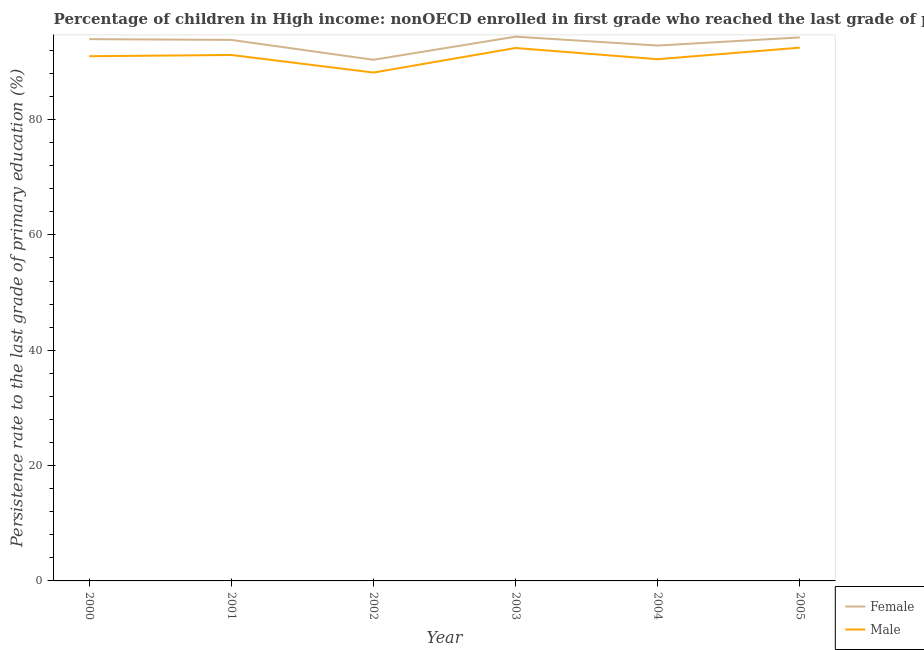Is the number of lines equal to the number of legend labels?
Ensure brevity in your answer.  Yes. What is the persistence rate of female students in 2004?
Provide a succinct answer. 92.84. Across all years, what is the maximum persistence rate of male students?
Give a very brief answer. 92.48. Across all years, what is the minimum persistence rate of male students?
Offer a very short reply. 88.16. In which year was the persistence rate of female students maximum?
Make the answer very short. 2003. What is the total persistence rate of male students in the graph?
Keep it short and to the point. 545.72. What is the difference between the persistence rate of female students in 2000 and that in 2004?
Keep it short and to the point. 1.11. What is the difference between the persistence rate of male students in 2005 and the persistence rate of female students in 2002?
Give a very brief answer. 2.1. What is the average persistence rate of male students per year?
Provide a short and direct response. 90.95. In the year 2001, what is the difference between the persistence rate of female students and persistence rate of male students?
Your answer should be very brief. 2.62. What is the ratio of the persistence rate of female students in 2004 to that in 2005?
Give a very brief answer. 0.99. What is the difference between the highest and the second highest persistence rate of female students?
Provide a succinct answer. 0.13. What is the difference between the highest and the lowest persistence rate of female students?
Your answer should be very brief. 4.01. Is the sum of the persistence rate of female students in 2001 and 2002 greater than the maximum persistence rate of male students across all years?
Make the answer very short. Yes. How many lines are there?
Offer a terse response. 2. How many years are there in the graph?
Keep it short and to the point. 6. What is the difference between two consecutive major ticks on the Y-axis?
Ensure brevity in your answer.  20. Are the values on the major ticks of Y-axis written in scientific E-notation?
Give a very brief answer. No. Does the graph contain any zero values?
Your answer should be compact. No. Where does the legend appear in the graph?
Provide a succinct answer. Bottom right. How many legend labels are there?
Your response must be concise. 2. How are the legend labels stacked?
Give a very brief answer. Vertical. What is the title of the graph?
Your answer should be compact. Percentage of children in High income: nonOECD enrolled in first grade who reached the last grade of primary education. What is the label or title of the X-axis?
Your answer should be compact. Year. What is the label or title of the Y-axis?
Provide a short and direct response. Persistence rate to the last grade of primary education (%). What is the Persistence rate to the last grade of primary education (%) in Female in 2000?
Your answer should be very brief. 93.95. What is the Persistence rate to the last grade of primary education (%) in Male in 2000?
Keep it short and to the point. 90.99. What is the Persistence rate to the last grade of primary education (%) of Female in 2001?
Your answer should be very brief. 93.82. What is the Persistence rate to the last grade of primary education (%) of Male in 2001?
Give a very brief answer. 91.21. What is the Persistence rate to the last grade of primary education (%) in Female in 2002?
Ensure brevity in your answer.  90.37. What is the Persistence rate to the last grade of primary education (%) of Male in 2002?
Your answer should be compact. 88.16. What is the Persistence rate to the last grade of primary education (%) in Female in 2003?
Your answer should be compact. 94.38. What is the Persistence rate to the last grade of primary education (%) of Male in 2003?
Offer a very short reply. 92.42. What is the Persistence rate to the last grade of primary education (%) in Female in 2004?
Your response must be concise. 92.84. What is the Persistence rate to the last grade of primary education (%) in Male in 2004?
Your answer should be compact. 90.47. What is the Persistence rate to the last grade of primary education (%) of Female in 2005?
Provide a short and direct response. 94.25. What is the Persistence rate to the last grade of primary education (%) in Male in 2005?
Provide a succinct answer. 92.48. Across all years, what is the maximum Persistence rate to the last grade of primary education (%) in Female?
Ensure brevity in your answer.  94.38. Across all years, what is the maximum Persistence rate to the last grade of primary education (%) of Male?
Your answer should be very brief. 92.48. Across all years, what is the minimum Persistence rate to the last grade of primary education (%) of Female?
Provide a short and direct response. 90.37. Across all years, what is the minimum Persistence rate to the last grade of primary education (%) of Male?
Your response must be concise. 88.16. What is the total Persistence rate to the last grade of primary education (%) of Female in the graph?
Your response must be concise. 559.62. What is the total Persistence rate to the last grade of primary education (%) in Male in the graph?
Provide a short and direct response. 545.72. What is the difference between the Persistence rate to the last grade of primary education (%) of Female in 2000 and that in 2001?
Your answer should be very brief. 0.13. What is the difference between the Persistence rate to the last grade of primary education (%) of Male in 2000 and that in 2001?
Provide a succinct answer. -0.21. What is the difference between the Persistence rate to the last grade of primary education (%) of Female in 2000 and that in 2002?
Ensure brevity in your answer.  3.58. What is the difference between the Persistence rate to the last grade of primary education (%) of Male in 2000 and that in 2002?
Offer a terse response. 2.83. What is the difference between the Persistence rate to the last grade of primary education (%) of Female in 2000 and that in 2003?
Provide a succinct answer. -0.43. What is the difference between the Persistence rate to the last grade of primary education (%) in Male in 2000 and that in 2003?
Provide a succinct answer. -1.43. What is the difference between the Persistence rate to the last grade of primary education (%) of Female in 2000 and that in 2004?
Your answer should be very brief. 1.11. What is the difference between the Persistence rate to the last grade of primary education (%) in Male in 2000 and that in 2004?
Offer a very short reply. 0.52. What is the difference between the Persistence rate to the last grade of primary education (%) in Female in 2000 and that in 2005?
Provide a short and direct response. -0.3. What is the difference between the Persistence rate to the last grade of primary education (%) in Male in 2000 and that in 2005?
Your response must be concise. -1.48. What is the difference between the Persistence rate to the last grade of primary education (%) of Female in 2001 and that in 2002?
Give a very brief answer. 3.45. What is the difference between the Persistence rate to the last grade of primary education (%) of Male in 2001 and that in 2002?
Offer a terse response. 3.05. What is the difference between the Persistence rate to the last grade of primary education (%) in Female in 2001 and that in 2003?
Provide a succinct answer. -0.56. What is the difference between the Persistence rate to the last grade of primary education (%) of Male in 2001 and that in 2003?
Provide a short and direct response. -1.21. What is the difference between the Persistence rate to the last grade of primary education (%) in Female in 2001 and that in 2004?
Your response must be concise. 0.98. What is the difference between the Persistence rate to the last grade of primary education (%) in Male in 2001 and that in 2004?
Make the answer very short. 0.73. What is the difference between the Persistence rate to the last grade of primary education (%) in Female in 2001 and that in 2005?
Keep it short and to the point. -0.43. What is the difference between the Persistence rate to the last grade of primary education (%) of Male in 2001 and that in 2005?
Your answer should be very brief. -1.27. What is the difference between the Persistence rate to the last grade of primary education (%) of Female in 2002 and that in 2003?
Your response must be concise. -4.01. What is the difference between the Persistence rate to the last grade of primary education (%) in Male in 2002 and that in 2003?
Your response must be concise. -4.26. What is the difference between the Persistence rate to the last grade of primary education (%) of Female in 2002 and that in 2004?
Keep it short and to the point. -2.47. What is the difference between the Persistence rate to the last grade of primary education (%) of Male in 2002 and that in 2004?
Ensure brevity in your answer.  -2.32. What is the difference between the Persistence rate to the last grade of primary education (%) of Female in 2002 and that in 2005?
Your answer should be compact. -3.88. What is the difference between the Persistence rate to the last grade of primary education (%) of Male in 2002 and that in 2005?
Give a very brief answer. -4.32. What is the difference between the Persistence rate to the last grade of primary education (%) in Female in 2003 and that in 2004?
Provide a succinct answer. 1.54. What is the difference between the Persistence rate to the last grade of primary education (%) in Male in 2003 and that in 2004?
Provide a short and direct response. 1.94. What is the difference between the Persistence rate to the last grade of primary education (%) in Female in 2003 and that in 2005?
Your answer should be very brief. 0.13. What is the difference between the Persistence rate to the last grade of primary education (%) in Male in 2003 and that in 2005?
Your answer should be very brief. -0.06. What is the difference between the Persistence rate to the last grade of primary education (%) of Female in 2004 and that in 2005?
Give a very brief answer. -1.41. What is the difference between the Persistence rate to the last grade of primary education (%) in Male in 2004 and that in 2005?
Your answer should be compact. -2. What is the difference between the Persistence rate to the last grade of primary education (%) in Female in 2000 and the Persistence rate to the last grade of primary education (%) in Male in 2001?
Provide a succinct answer. 2.75. What is the difference between the Persistence rate to the last grade of primary education (%) in Female in 2000 and the Persistence rate to the last grade of primary education (%) in Male in 2002?
Provide a short and direct response. 5.79. What is the difference between the Persistence rate to the last grade of primary education (%) in Female in 2000 and the Persistence rate to the last grade of primary education (%) in Male in 2003?
Your answer should be compact. 1.54. What is the difference between the Persistence rate to the last grade of primary education (%) in Female in 2000 and the Persistence rate to the last grade of primary education (%) in Male in 2004?
Make the answer very short. 3.48. What is the difference between the Persistence rate to the last grade of primary education (%) in Female in 2000 and the Persistence rate to the last grade of primary education (%) in Male in 2005?
Give a very brief answer. 1.48. What is the difference between the Persistence rate to the last grade of primary education (%) of Female in 2001 and the Persistence rate to the last grade of primary education (%) of Male in 2002?
Your answer should be compact. 5.66. What is the difference between the Persistence rate to the last grade of primary education (%) in Female in 2001 and the Persistence rate to the last grade of primary education (%) in Male in 2003?
Your response must be concise. 1.4. What is the difference between the Persistence rate to the last grade of primary education (%) of Female in 2001 and the Persistence rate to the last grade of primary education (%) of Male in 2004?
Make the answer very short. 3.35. What is the difference between the Persistence rate to the last grade of primary education (%) in Female in 2001 and the Persistence rate to the last grade of primary education (%) in Male in 2005?
Offer a terse response. 1.34. What is the difference between the Persistence rate to the last grade of primary education (%) of Female in 2002 and the Persistence rate to the last grade of primary education (%) of Male in 2003?
Provide a succinct answer. -2.04. What is the difference between the Persistence rate to the last grade of primary education (%) in Female in 2002 and the Persistence rate to the last grade of primary education (%) in Male in 2004?
Your answer should be compact. -0.1. What is the difference between the Persistence rate to the last grade of primary education (%) of Female in 2002 and the Persistence rate to the last grade of primary education (%) of Male in 2005?
Ensure brevity in your answer.  -2.1. What is the difference between the Persistence rate to the last grade of primary education (%) in Female in 2003 and the Persistence rate to the last grade of primary education (%) in Male in 2004?
Ensure brevity in your answer.  3.91. What is the difference between the Persistence rate to the last grade of primary education (%) in Female in 2003 and the Persistence rate to the last grade of primary education (%) in Male in 2005?
Your response must be concise. 1.9. What is the difference between the Persistence rate to the last grade of primary education (%) in Female in 2004 and the Persistence rate to the last grade of primary education (%) in Male in 2005?
Your response must be concise. 0.37. What is the average Persistence rate to the last grade of primary education (%) in Female per year?
Ensure brevity in your answer.  93.27. What is the average Persistence rate to the last grade of primary education (%) in Male per year?
Provide a short and direct response. 90.95. In the year 2000, what is the difference between the Persistence rate to the last grade of primary education (%) of Female and Persistence rate to the last grade of primary education (%) of Male?
Keep it short and to the point. 2.96. In the year 2001, what is the difference between the Persistence rate to the last grade of primary education (%) of Female and Persistence rate to the last grade of primary education (%) of Male?
Your response must be concise. 2.62. In the year 2002, what is the difference between the Persistence rate to the last grade of primary education (%) in Female and Persistence rate to the last grade of primary education (%) in Male?
Your answer should be very brief. 2.22. In the year 2003, what is the difference between the Persistence rate to the last grade of primary education (%) of Female and Persistence rate to the last grade of primary education (%) of Male?
Ensure brevity in your answer.  1.96. In the year 2004, what is the difference between the Persistence rate to the last grade of primary education (%) in Female and Persistence rate to the last grade of primary education (%) in Male?
Your answer should be very brief. 2.37. In the year 2005, what is the difference between the Persistence rate to the last grade of primary education (%) in Female and Persistence rate to the last grade of primary education (%) in Male?
Keep it short and to the point. 1.77. What is the ratio of the Persistence rate to the last grade of primary education (%) in Female in 2000 to that in 2002?
Keep it short and to the point. 1.04. What is the ratio of the Persistence rate to the last grade of primary education (%) of Male in 2000 to that in 2002?
Provide a succinct answer. 1.03. What is the ratio of the Persistence rate to the last grade of primary education (%) of Female in 2000 to that in 2003?
Give a very brief answer. 1. What is the ratio of the Persistence rate to the last grade of primary education (%) of Male in 2000 to that in 2003?
Provide a short and direct response. 0.98. What is the ratio of the Persistence rate to the last grade of primary education (%) of Male in 2000 to that in 2004?
Your answer should be compact. 1.01. What is the ratio of the Persistence rate to the last grade of primary education (%) of Female in 2000 to that in 2005?
Keep it short and to the point. 1. What is the ratio of the Persistence rate to the last grade of primary education (%) of Male in 2000 to that in 2005?
Offer a very short reply. 0.98. What is the ratio of the Persistence rate to the last grade of primary education (%) in Female in 2001 to that in 2002?
Your answer should be very brief. 1.04. What is the ratio of the Persistence rate to the last grade of primary education (%) of Male in 2001 to that in 2002?
Your answer should be compact. 1.03. What is the ratio of the Persistence rate to the last grade of primary education (%) of Female in 2001 to that in 2003?
Ensure brevity in your answer.  0.99. What is the ratio of the Persistence rate to the last grade of primary education (%) of Male in 2001 to that in 2003?
Offer a terse response. 0.99. What is the ratio of the Persistence rate to the last grade of primary education (%) of Female in 2001 to that in 2004?
Give a very brief answer. 1.01. What is the ratio of the Persistence rate to the last grade of primary education (%) in Male in 2001 to that in 2004?
Provide a short and direct response. 1.01. What is the ratio of the Persistence rate to the last grade of primary education (%) of Female in 2001 to that in 2005?
Make the answer very short. 1. What is the ratio of the Persistence rate to the last grade of primary education (%) in Male in 2001 to that in 2005?
Your answer should be very brief. 0.99. What is the ratio of the Persistence rate to the last grade of primary education (%) of Female in 2002 to that in 2003?
Your response must be concise. 0.96. What is the ratio of the Persistence rate to the last grade of primary education (%) in Male in 2002 to that in 2003?
Keep it short and to the point. 0.95. What is the ratio of the Persistence rate to the last grade of primary education (%) in Female in 2002 to that in 2004?
Your response must be concise. 0.97. What is the ratio of the Persistence rate to the last grade of primary education (%) of Male in 2002 to that in 2004?
Keep it short and to the point. 0.97. What is the ratio of the Persistence rate to the last grade of primary education (%) in Female in 2002 to that in 2005?
Offer a very short reply. 0.96. What is the ratio of the Persistence rate to the last grade of primary education (%) in Male in 2002 to that in 2005?
Provide a short and direct response. 0.95. What is the ratio of the Persistence rate to the last grade of primary education (%) in Female in 2003 to that in 2004?
Keep it short and to the point. 1.02. What is the ratio of the Persistence rate to the last grade of primary education (%) of Male in 2003 to that in 2004?
Provide a short and direct response. 1.02. What is the ratio of the Persistence rate to the last grade of primary education (%) of Female in 2004 to that in 2005?
Your answer should be very brief. 0.99. What is the ratio of the Persistence rate to the last grade of primary education (%) in Male in 2004 to that in 2005?
Give a very brief answer. 0.98. What is the difference between the highest and the second highest Persistence rate to the last grade of primary education (%) in Female?
Ensure brevity in your answer.  0.13. What is the difference between the highest and the second highest Persistence rate to the last grade of primary education (%) in Male?
Your answer should be very brief. 0.06. What is the difference between the highest and the lowest Persistence rate to the last grade of primary education (%) of Female?
Make the answer very short. 4.01. What is the difference between the highest and the lowest Persistence rate to the last grade of primary education (%) of Male?
Offer a very short reply. 4.32. 